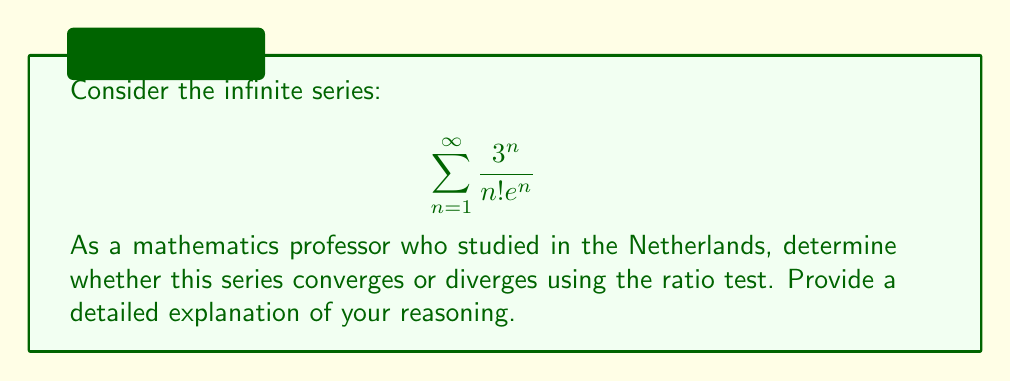Help me with this question. To determine the convergence of this series using the ratio test, we need to calculate the limit of the ratio of consecutive terms as n approaches infinity. Let's follow these steps:

1) Let $a_n = \frac{3^n}{n!e^n}$ be the general term of the series.

2) Form the ratio of consecutive terms:

   $$\lim_{n \to \infty} \left|\frac{a_{n+1}}{a_n}\right| = \lim_{n \to \infty} \left|\frac{\frac{3^{n+1}}{(n+1)!e^{n+1}}}{\frac{3^n}{n!e^n}}\right|$$

3) Simplify the ratio:

   $$\lim_{n \to \infty} \left|\frac{3^{n+1}}{(n+1)!e^{n+1}} \cdot \frac{n!e^n}{3^n}\right| = \lim_{n \to \infty} \left|\frac{3 \cdot n!}{(n+1)! \cdot e}\right|$$

4) Simplify further:

   $$\lim_{n \to \infty} \left|\frac{3}{(n+1)e}\right|$$

5) Evaluate the limit:

   $$\lim_{n \to \infty} \frac{3}{(n+1)e} = 0$$

6) Apply the ratio test:
   - If the limit is less than 1, the series converges.
   - If the limit is greater than 1, the series diverges.
   - If the limit equals 1, the test is inconclusive.

In this case, the limit is 0, which is less than 1.

Therefore, by the ratio test, we can conclude that the series converges.
Answer: The series $\sum_{n=1}^{\infty} \frac{3^n}{n!e^n}$ converges. 